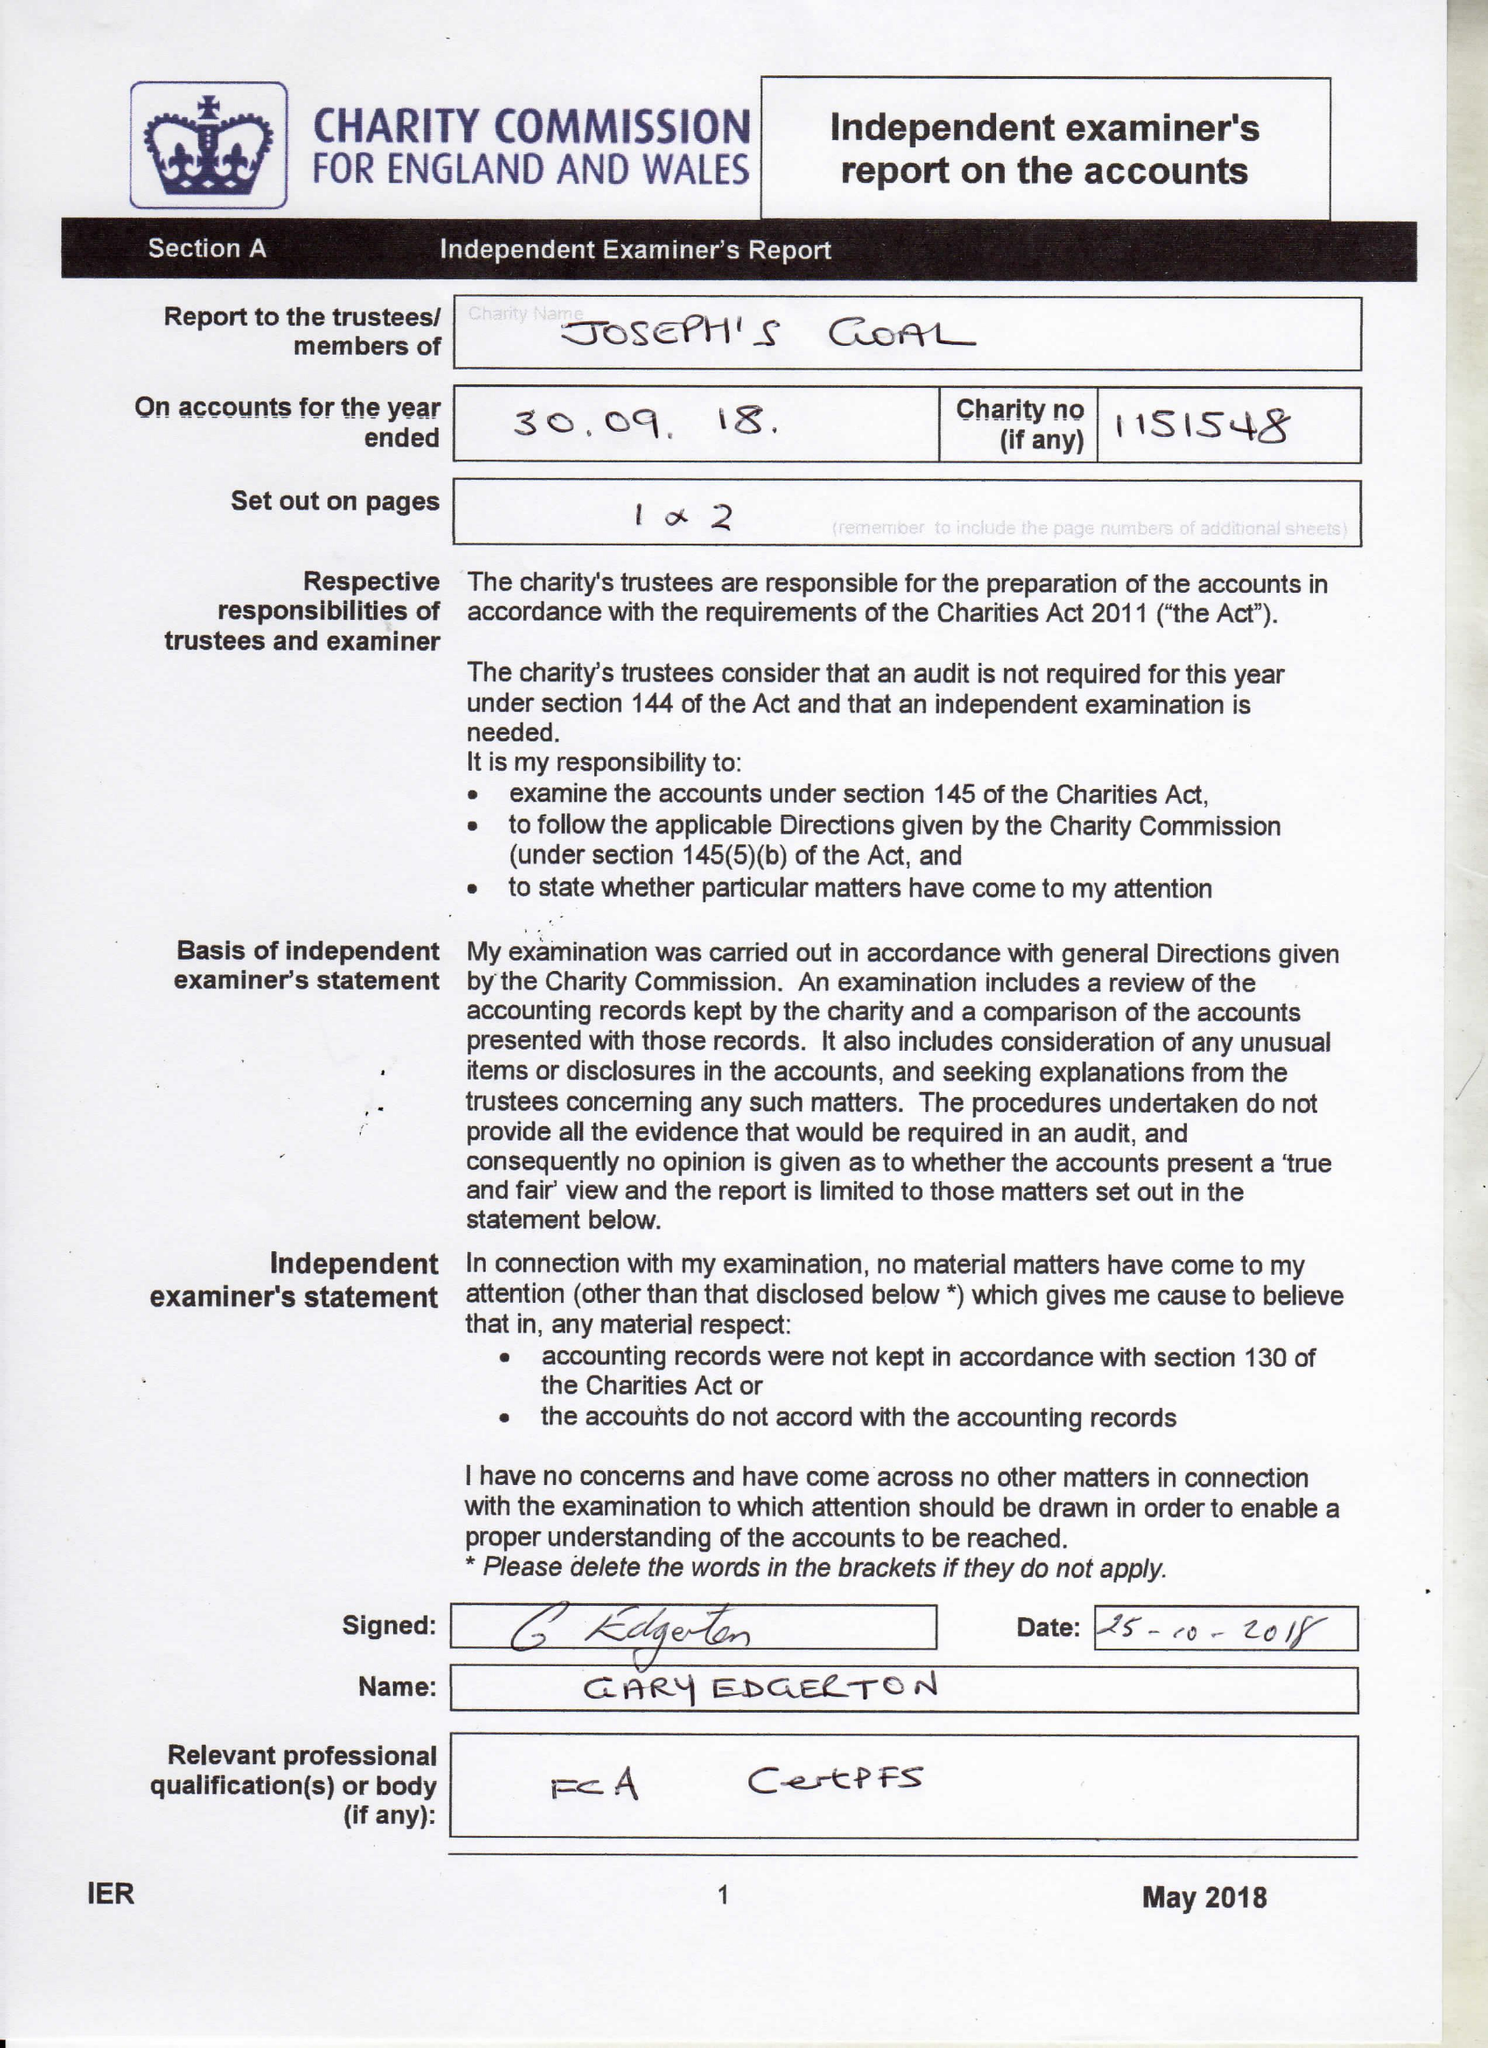What is the value for the charity_name?
Answer the question using a single word or phrase. Joseph's Goal 